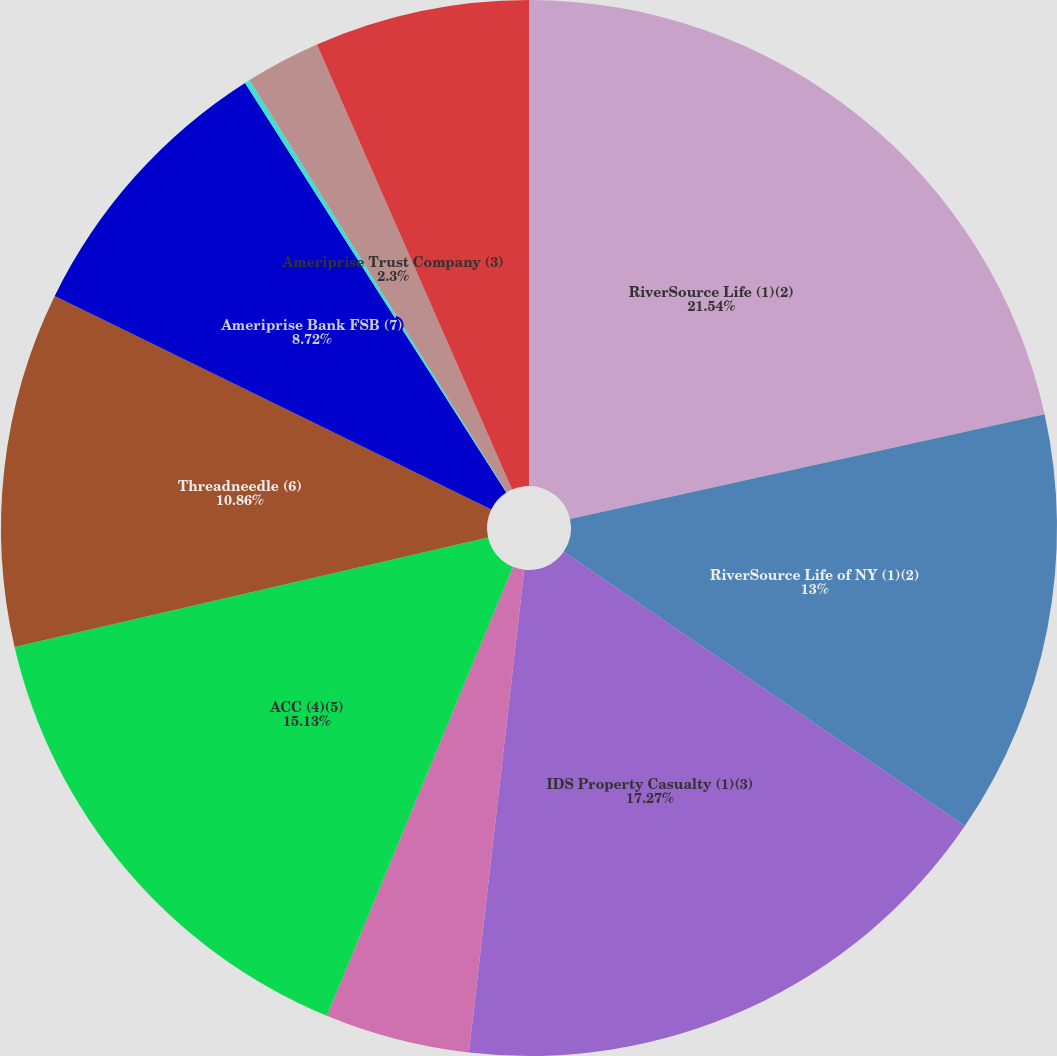<chart> <loc_0><loc_0><loc_500><loc_500><pie_chart><fcel>RiverSource Life (1)(2)<fcel>RiverSource Life of NY (1)(2)<fcel>IDS Property Casualty (1)(3)<fcel>Ameriprise Insurance Company<fcel>ACC (4)(5)<fcel>Threadneedle (6)<fcel>Ameriprise Bank FSB (7)<fcel>Ameriprise Captive Insurance<fcel>Ameriprise Trust Company (3)<fcel>AEIS (3)(4)<nl><fcel>21.55%<fcel>13.0%<fcel>17.27%<fcel>4.44%<fcel>15.13%<fcel>10.86%<fcel>8.72%<fcel>0.16%<fcel>2.3%<fcel>6.58%<nl></chart> 